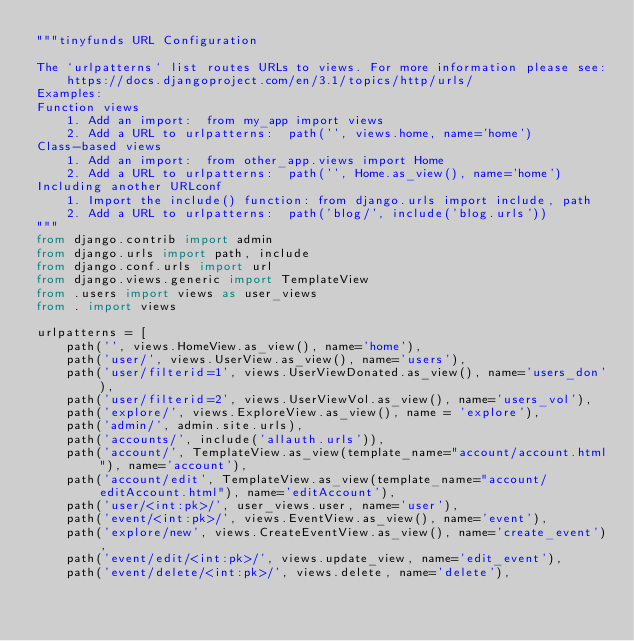<code> <loc_0><loc_0><loc_500><loc_500><_Python_>"""tinyfunds URL Configuration

The `urlpatterns` list routes URLs to views. For more information please see:
    https://docs.djangoproject.com/en/3.1/topics/http/urls/
Examples:
Function views
    1. Add an import:  from my_app import views
    2. Add a URL to urlpatterns:  path('', views.home, name='home')
Class-based views
    1. Add an import:  from other_app.views import Home
    2. Add a URL to urlpatterns:  path('', Home.as_view(), name='home')
Including another URLconf
    1. Import the include() function: from django.urls import include, path
    2. Add a URL to urlpatterns:  path('blog/', include('blog.urls'))
"""
from django.contrib import admin
from django.urls import path, include
from django.conf.urls import url
from django.views.generic import TemplateView
from .users import views as user_views
from . import views

urlpatterns = [
    path('', views.HomeView.as_view(), name='home'),
    path('user/', views.UserView.as_view(), name='users'),
    path('user/filterid=1', views.UserViewDonated.as_view(), name='users_don'),
    path('user/filterid=2', views.UserViewVol.as_view(), name='users_vol'),
    path('explore/', views.ExploreView.as_view(), name = 'explore'),
    path('admin/', admin.site.urls),
    path('accounts/', include('allauth.urls')),
    path('account/', TemplateView.as_view(template_name="account/account.html"), name='account'),
    path('account/edit', TemplateView.as_view(template_name="account/editAccount.html"), name='editAccount'),
    path('user/<int:pk>/', user_views.user, name='user'),
    path('event/<int:pk>/', views.EventView.as_view(), name='event'),
    path('explore/new', views.CreateEventView.as_view(), name='create_event'),
    path('event/edit/<int:pk>/', views.update_view, name='edit_event'),
    path('event/delete/<int:pk>/', views.delete, name='delete'),</code> 